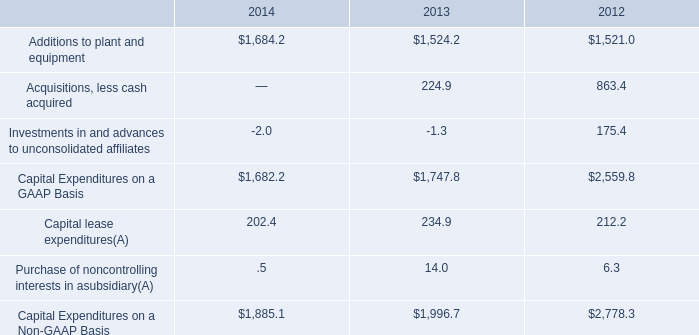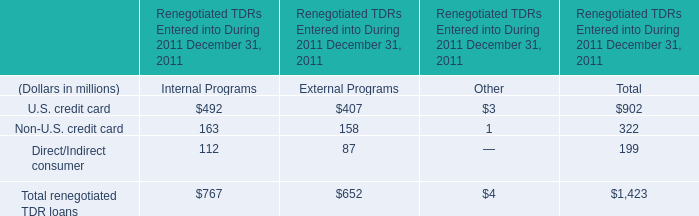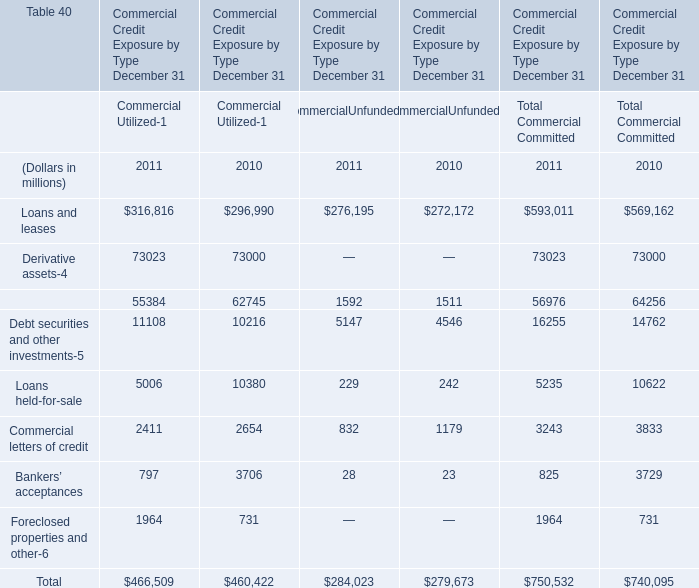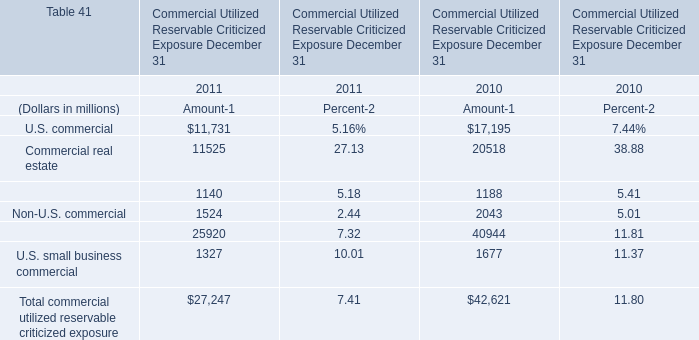Which year is U.S. commercial the lowest for amount? 
Answer: 2011. 